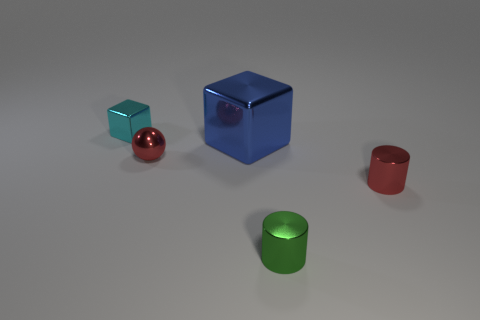Subtract all green cylinders. How many cylinders are left? 1 Subtract 1 cylinders. How many cylinders are left? 1 Subtract all cubes. How many objects are left? 3 Subtract all brown cylinders. Subtract all cyan cubes. How many cylinders are left? 2 Subtract all red spheres. How many red blocks are left? 0 Subtract all small green metal cylinders. Subtract all small shiny things. How many objects are left? 0 Add 4 small green metal cylinders. How many small green metal cylinders are left? 5 Add 3 cubes. How many cubes exist? 5 Add 2 gray rubber cubes. How many objects exist? 7 Subtract 0 yellow cubes. How many objects are left? 5 